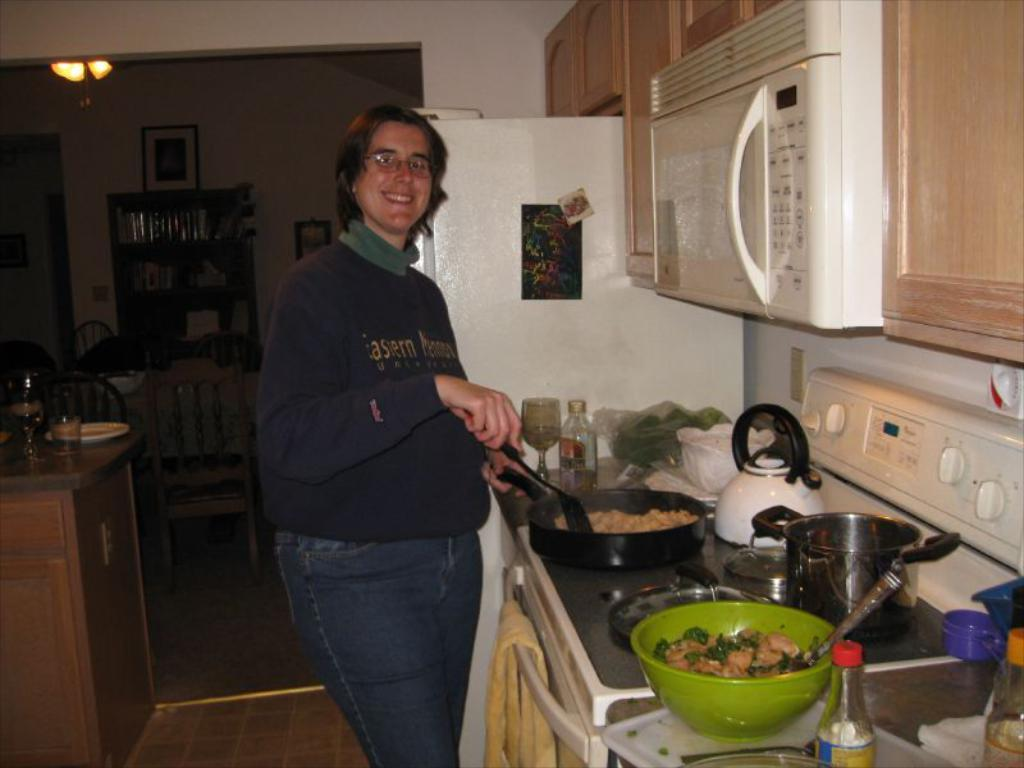<image>
Relay a brief, clear account of the picture shown. A woman cooking, on her jumper the word Eastern is displayed. 